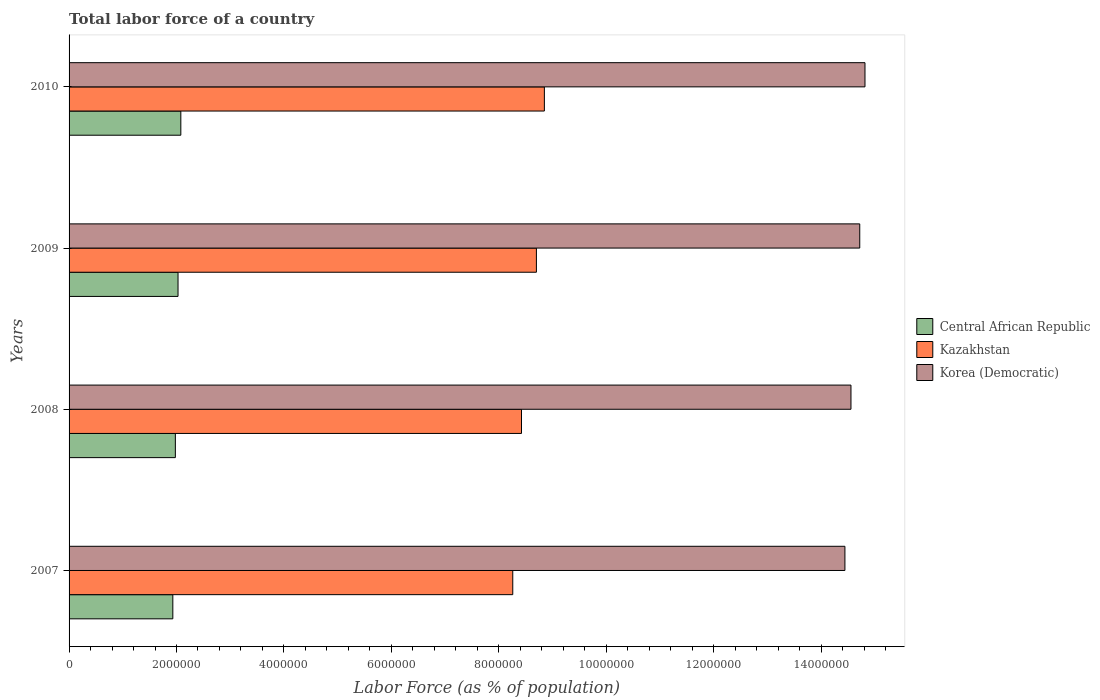Are the number of bars on each tick of the Y-axis equal?
Provide a short and direct response. Yes. How many bars are there on the 2nd tick from the top?
Keep it short and to the point. 3. In how many cases, is the number of bars for a given year not equal to the number of legend labels?
Make the answer very short. 0. What is the percentage of labor force in Kazakhstan in 2007?
Ensure brevity in your answer.  8.26e+06. Across all years, what is the maximum percentage of labor force in Central African Republic?
Keep it short and to the point. 2.08e+06. Across all years, what is the minimum percentage of labor force in Kazakhstan?
Your response must be concise. 8.26e+06. What is the total percentage of labor force in Korea (Democratic) in the graph?
Provide a succinct answer. 5.85e+07. What is the difference between the percentage of labor force in Korea (Democratic) in 2008 and that in 2010?
Offer a terse response. -2.61e+05. What is the difference between the percentage of labor force in Korea (Democratic) in 2010 and the percentage of labor force in Central African Republic in 2009?
Give a very brief answer. 1.28e+07. What is the average percentage of labor force in Korea (Democratic) per year?
Offer a terse response. 1.46e+07. In the year 2007, what is the difference between the percentage of labor force in Kazakhstan and percentage of labor force in Central African Republic?
Keep it short and to the point. 6.33e+06. What is the ratio of the percentage of labor force in Korea (Democratic) in 2007 to that in 2008?
Offer a very short reply. 0.99. Is the percentage of labor force in Korea (Democratic) in 2007 less than that in 2008?
Offer a terse response. Yes. Is the difference between the percentage of labor force in Kazakhstan in 2009 and 2010 greater than the difference between the percentage of labor force in Central African Republic in 2009 and 2010?
Your answer should be very brief. No. What is the difference between the highest and the second highest percentage of labor force in Korea (Democratic)?
Ensure brevity in your answer.  9.74e+04. What is the difference between the highest and the lowest percentage of labor force in Central African Republic?
Your answer should be very brief. 1.49e+05. What does the 2nd bar from the top in 2010 represents?
Make the answer very short. Kazakhstan. What does the 1st bar from the bottom in 2010 represents?
Offer a very short reply. Central African Republic. Is it the case that in every year, the sum of the percentage of labor force in Korea (Democratic) and percentage of labor force in Kazakhstan is greater than the percentage of labor force in Central African Republic?
Your answer should be very brief. Yes. Are all the bars in the graph horizontal?
Ensure brevity in your answer.  Yes. How many years are there in the graph?
Your response must be concise. 4. Are the values on the major ticks of X-axis written in scientific E-notation?
Keep it short and to the point. No. How are the legend labels stacked?
Provide a succinct answer. Vertical. What is the title of the graph?
Offer a very short reply. Total labor force of a country. What is the label or title of the X-axis?
Make the answer very short. Labor Force (as % of population). What is the label or title of the Y-axis?
Ensure brevity in your answer.  Years. What is the Labor Force (as % of population) in Central African Republic in 2007?
Provide a short and direct response. 1.93e+06. What is the Labor Force (as % of population) of Kazakhstan in 2007?
Keep it short and to the point. 8.26e+06. What is the Labor Force (as % of population) of Korea (Democratic) in 2007?
Provide a short and direct response. 1.44e+07. What is the Labor Force (as % of population) of Central African Republic in 2008?
Keep it short and to the point. 1.98e+06. What is the Labor Force (as % of population) of Kazakhstan in 2008?
Make the answer very short. 8.42e+06. What is the Labor Force (as % of population) in Korea (Democratic) in 2008?
Provide a short and direct response. 1.46e+07. What is the Labor Force (as % of population) of Central African Republic in 2009?
Provide a succinct answer. 2.03e+06. What is the Labor Force (as % of population) of Kazakhstan in 2009?
Offer a very short reply. 8.70e+06. What is the Labor Force (as % of population) in Korea (Democratic) in 2009?
Offer a very short reply. 1.47e+07. What is the Labor Force (as % of population) in Central African Republic in 2010?
Offer a terse response. 2.08e+06. What is the Labor Force (as % of population) in Kazakhstan in 2010?
Your response must be concise. 8.85e+06. What is the Labor Force (as % of population) in Korea (Democratic) in 2010?
Provide a succinct answer. 1.48e+07. Across all years, what is the maximum Labor Force (as % of population) of Central African Republic?
Your answer should be compact. 2.08e+06. Across all years, what is the maximum Labor Force (as % of population) in Kazakhstan?
Make the answer very short. 8.85e+06. Across all years, what is the maximum Labor Force (as % of population) in Korea (Democratic)?
Keep it short and to the point. 1.48e+07. Across all years, what is the minimum Labor Force (as % of population) of Central African Republic?
Your answer should be very brief. 1.93e+06. Across all years, what is the minimum Labor Force (as % of population) of Kazakhstan?
Provide a short and direct response. 8.26e+06. Across all years, what is the minimum Labor Force (as % of population) in Korea (Democratic)?
Your answer should be very brief. 1.44e+07. What is the total Labor Force (as % of population) of Central African Republic in the graph?
Your answer should be compact. 8.02e+06. What is the total Labor Force (as % of population) of Kazakhstan in the graph?
Your answer should be compact. 3.42e+07. What is the total Labor Force (as % of population) of Korea (Democratic) in the graph?
Offer a very short reply. 5.85e+07. What is the difference between the Labor Force (as % of population) in Central African Republic in 2007 and that in 2008?
Your answer should be compact. -4.70e+04. What is the difference between the Labor Force (as % of population) of Kazakhstan in 2007 and that in 2008?
Keep it short and to the point. -1.63e+05. What is the difference between the Labor Force (as % of population) of Korea (Democratic) in 2007 and that in 2008?
Your answer should be compact. -1.13e+05. What is the difference between the Labor Force (as % of population) in Central African Republic in 2007 and that in 2009?
Offer a terse response. -9.67e+04. What is the difference between the Labor Force (as % of population) of Kazakhstan in 2007 and that in 2009?
Keep it short and to the point. -4.40e+05. What is the difference between the Labor Force (as % of population) in Korea (Democratic) in 2007 and that in 2009?
Provide a short and direct response. -2.76e+05. What is the difference between the Labor Force (as % of population) in Central African Republic in 2007 and that in 2010?
Offer a very short reply. -1.49e+05. What is the difference between the Labor Force (as % of population) of Kazakhstan in 2007 and that in 2010?
Your response must be concise. -5.88e+05. What is the difference between the Labor Force (as % of population) in Korea (Democratic) in 2007 and that in 2010?
Keep it short and to the point. -3.73e+05. What is the difference between the Labor Force (as % of population) in Central African Republic in 2008 and that in 2009?
Offer a very short reply. -4.98e+04. What is the difference between the Labor Force (as % of population) of Kazakhstan in 2008 and that in 2009?
Offer a terse response. -2.78e+05. What is the difference between the Labor Force (as % of population) of Korea (Democratic) in 2008 and that in 2009?
Give a very brief answer. -1.63e+05. What is the difference between the Labor Force (as % of population) in Central African Republic in 2008 and that in 2010?
Offer a terse response. -1.02e+05. What is the difference between the Labor Force (as % of population) in Kazakhstan in 2008 and that in 2010?
Provide a short and direct response. -4.26e+05. What is the difference between the Labor Force (as % of population) of Korea (Democratic) in 2008 and that in 2010?
Your response must be concise. -2.61e+05. What is the difference between the Labor Force (as % of population) of Central African Republic in 2009 and that in 2010?
Give a very brief answer. -5.22e+04. What is the difference between the Labor Force (as % of population) of Kazakhstan in 2009 and that in 2010?
Your response must be concise. -1.48e+05. What is the difference between the Labor Force (as % of population) of Korea (Democratic) in 2009 and that in 2010?
Your answer should be very brief. -9.74e+04. What is the difference between the Labor Force (as % of population) of Central African Republic in 2007 and the Labor Force (as % of population) of Kazakhstan in 2008?
Make the answer very short. -6.49e+06. What is the difference between the Labor Force (as % of population) in Central African Republic in 2007 and the Labor Force (as % of population) in Korea (Democratic) in 2008?
Make the answer very short. -1.26e+07. What is the difference between the Labor Force (as % of population) in Kazakhstan in 2007 and the Labor Force (as % of population) in Korea (Democratic) in 2008?
Your answer should be very brief. -6.30e+06. What is the difference between the Labor Force (as % of population) of Central African Republic in 2007 and the Labor Force (as % of population) of Kazakhstan in 2009?
Your answer should be compact. -6.77e+06. What is the difference between the Labor Force (as % of population) of Central African Republic in 2007 and the Labor Force (as % of population) of Korea (Democratic) in 2009?
Your answer should be compact. -1.28e+07. What is the difference between the Labor Force (as % of population) in Kazakhstan in 2007 and the Labor Force (as % of population) in Korea (Democratic) in 2009?
Provide a short and direct response. -6.46e+06. What is the difference between the Labor Force (as % of population) of Central African Republic in 2007 and the Labor Force (as % of population) of Kazakhstan in 2010?
Provide a short and direct response. -6.92e+06. What is the difference between the Labor Force (as % of population) in Central African Republic in 2007 and the Labor Force (as % of population) in Korea (Democratic) in 2010?
Make the answer very short. -1.29e+07. What is the difference between the Labor Force (as % of population) in Kazakhstan in 2007 and the Labor Force (as % of population) in Korea (Democratic) in 2010?
Your answer should be very brief. -6.56e+06. What is the difference between the Labor Force (as % of population) of Central African Republic in 2008 and the Labor Force (as % of population) of Kazakhstan in 2009?
Provide a short and direct response. -6.72e+06. What is the difference between the Labor Force (as % of population) of Central African Republic in 2008 and the Labor Force (as % of population) of Korea (Democratic) in 2009?
Make the answer very short. -1.27e+07. What is the difference between the Labor Force (as % of population) in Kazakhstan in 2008 and the Labor Force (as % of population) in Korea (Democratic) in 2009?
Your answer should be compact. -6.30e+06. What is the difference between the Labor Force (as % of population) in Central African Republic in 2008 and the Labor Force (as % of population) in Kazakhstan in 2010?
Your response must be concise. -6.87e+06. What is the difference between the Labor Force (as % of population) of Central African Republic in 2008 and the Labor Force (as % of population) of Korea (Democratic) in 2010?
Provide a succinct answer. -1.28e+07. What is the difference between the Labor Force (as % of population) of Kazakhstan in 2008 and the Labor Force (as % of population) of Korea (Democratic) in 2010?
Provide a succinct answer. -6.39e+06. What is the difference between the Labor Force (as % of population) in Central African Republic in 2009 and the Labor Force (as % of population) in Kazakhstan in 2010?
Give a very brief answer. -6.82e+06. What is the difference between the Labor Force (as % of population) of Central African Republic in 2009 and the Labor Force (as % of population) of Korea (Democratic) in 2010?
Your answer should be compact. -1.28e+07. What is the difference between the Labor Force (as % of population) in Kazakhstan in 2009 and the Labor Force (as % of population) in Korea (Democratic) in 2010?
Your answer should be compact. -6.12e+06. What is the average Labor Force (as % of population) in Central African Republic per year?
Provide a succinct answer. 2.00e+06. What is the average Labor Force (as % of population) of Kazakhstan per year?
Your answer should be compact. 8.56e+06. What is the average Labor Force (as % of population) in Korea (Democratic) per year?
Your response must be concise. 1.46e+07. In the year 2007, what is the difference between the Labor Force (as % of population) in Central African Republic and Labor Force (as % of population) in Kazakhstan?
Your answer should be very brief. -6.33e+06. In the year 2007, what is the difference between the Labor Force (as % of population) in Central African Republic and Labor Force (as % of population) in Korea (Democratic)?
Your answer should be very brief. -1.25e+07. In the year 2007, what is the difference between the Labor Force (as % of population) in Kazakhstan and Labor Force (as % of population) in Korea (Democratic)?
Keep it short and to the point. -6.18e+06. In the year 2008, what is the difference between the Labor Force (as % of population) of Central African Republic and Labor Force (as % of population) of Kazakhstan?
Provide a succinct answer. -6.44e+06. In the year 2008, what is the difference between the Labor Force (as % of population) in Central African Republic and Labor Force (as % of population) in Korea (Democratic)?
Ensure brevity in your answer.  -1.26e+07. In the year 2008, what is the difference between the Labor Force (as % of population) of Kazakhstan and Labor Force (as % of population) of Korea (Democratic)?
Offer a terse response. -6.13e+06. In the year 2009, what is the difference between the Labor Force (as % of population) in Central African Republic and Labor Force (as % of population) in Kazakhstan?
Offer a terse response. -6.67e+06. In the year 2009, what is the difference between the Labor Force (as % of population) of Central African Republic and Labor Force (as % of population) of Korea (Democratic)?
Offer a very short reply. -1.27e+07. In the year 2009, what is the difference between the Labor Force (as % of population) in Kazakhstan and Labor Force (as % of population) in Korea (Democratic)?
Offer a very short reply. -6.02e+06. In the year 2010, what is the difference between the Labor Force (as % of population) of Central African Republic and Labor Force (as % of population) of Kazakhstan?
Offer a terse response. -6.77e+06. In the year 2010, what is the difference between the Labor Force (as % of population) in Central African Republic and Labor Force (as % of population) in Korea (Democratic)?
Offer a terse response. -1.27e+07. In the year 2010, what is the difference between the Labor Force (as % of population) of Kazakhstan and Labor Force (as % of population) of Korea (Democratic)?
Offer a terse response. -5.97e+06. What is the ratio of the Labor Force (as % of population) in Central African Republic in 2007 to that in 2008?
Give a very brief answer. 0.98. What is the ratio of the Labor Force (as % of population) in Kazakhstan in 2007 to that in 2008?
Make the answer very short. 0.98. What is the ratio of the Labor Force (as % of population) of Korea (Democratic) in 2007 to that in 2008?
Provide a short and direct response. 0.99. What is the ratio of the Labor Force (as % of population) in Central African Republic in 2007 to that in 2009?
Give a very brief answer. 0.95. What is the ratio of the Labor Force (as % of population) of Kazakhstan in 2007 to that in 2009?
Give a very brief answer. 0.95. What is the ratio of the Labor Force (as % of population) of Korea (Democratic) in 2007 to that in 2009?
Provide a short and direct response. 0.98. What is the ratio of the Labor Force (as % of population) of Central African Republic in 2007 to that in 2010?
Your answer should be compact. 0.93. What is the ratio of the Labor Force (as % of population) of Kazakhstan in 2007 to that in 2010?
Offer a very short reply. 0.93. What is the ratio of the Labor Force (as % of population) in Korea (Democratic) in 2007 to that in 2010?
Make the answer very short. 0.97. What is the ratio of the Labor Force (as % of population) in Central African Republic in 2008 to that in 2009?
Give a very brief answer. 0.98. What is the ratio of the Labor Force (as % of population) of Kazakhstan in 2008 to that in 2009?
Your answer should be very brief. 0.97. What is the ratio of the Labor Force (as % of population) in Korea (Democratic) in 2008 to that in 2009?
Offer a very short reply. 0.99. What is the ratio of the Labor Force (as % of population) in Central African Republic in 2008 to that in 2010?
Offer a terse response. 0.95. What is the ratio of the Labor Force (as % of population) of Kazakhstan in 2008 to that in 2010?
Your answer should be compact. 0.95. What is the ratio of the Labor Force (as % of population) in Korea (Democratic) in 2008 to that in 2010?
Keep it short and to the point. 0.98. What is the ratio of the Labor Force (as % of population) in Central African Republic in 2009 to that in 2010?
Offer a very short reply. 0.97. What is the ratio of the Labor Force (as % of population) of Kazakhstan in 2009 to that in 2010?
Ensure brevity in your answer.  0.98. What is the difference between the highest and the second highest Labor Force (as % of population) in Central African Republic?
Provide a succinct answer. 5.22e+04. What is the difference between the highest and the second highest Labor Force (as % of population) of Kazakhstan?
Give a very brief answer. 1.48e+05. What is the difference between the highest and the second highest Labor Force (as % of population) in Korea (Democratic)?
Your response must be concise. 9.74e+04. What is the difference between the highest and the lowest Labor Force (as % of population) of Central African Republic?
Give a very brief answer. 1.49e+05. What is the difference between the highest and the lowest Labor Force (as % of population) in Kazakhstan?
Offer a terse response. 5.88e+05. What is the difference between the highest and the lowest Labor Force (as % of population) of Korea (Democratic)?
Ensure brevity in your answer.  3.73e+05. 